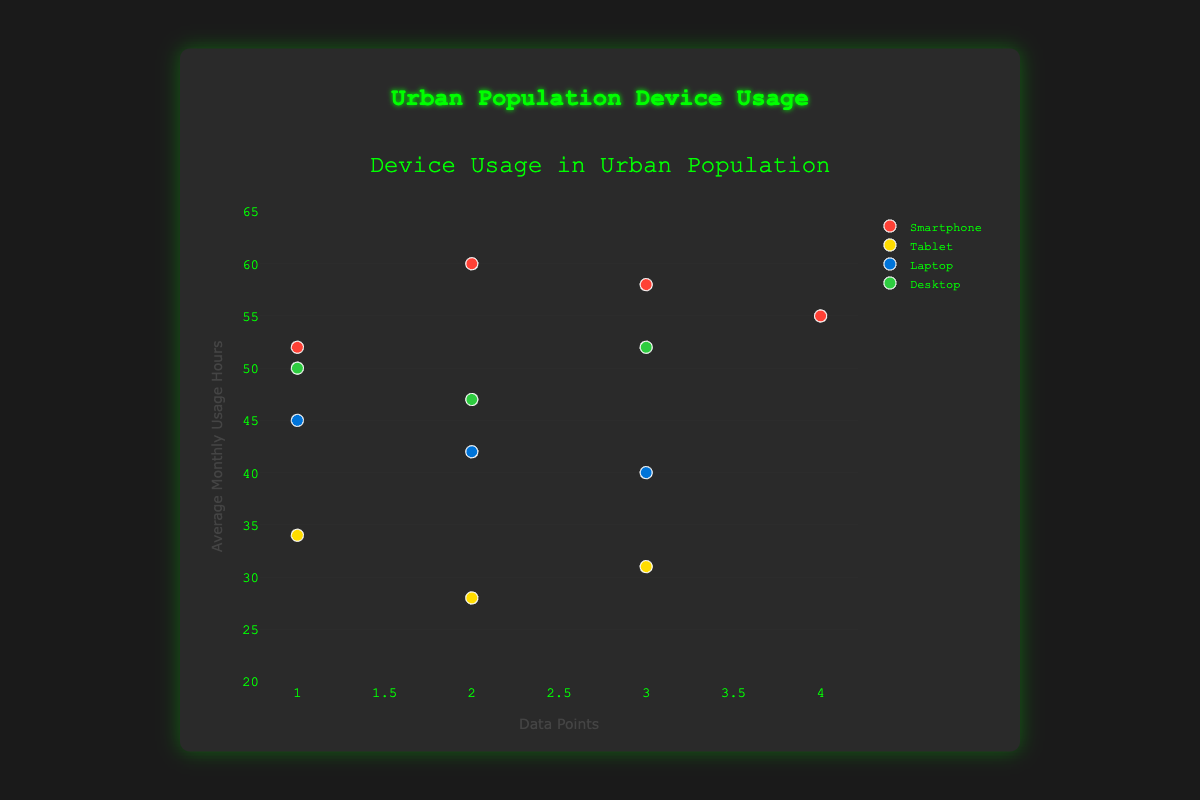How many different device types are represented in the scatter plot? The scatter plot shows different types of devices used in an urban population. By looking at the legend, you can see different markers representing different device types. There are four legend values corresponding to the device types: Smartphone, Tablet, Laptop, and Desktop
Answer: 4 Which device type has the data point with the highest average monthly usage hours? By visually inspecting the y-axis values, the highest data point is at 60 hours in the plot. Looking at the legend and the color of the marker, it is a Smartphone
Answer: Smartphone What is the range of average monthly usage hours for Desktops? To find the range, look for the minimum and maximum y-values of the "Desktop" markers in the scatter plot. The highest is 52 and the lowest is 47. The range is calculated as the difference between the maximum and minimum
Answer: 47 - 52 Comparing Smartphones and Tablets, which device type generally has higher average monthly usage hours? By comparing the y-values of the markers for Smartphones and Tablets, it's clear that the data points for Smartphones are generally higher, indicating that Smartphones have higher usage hours than Tablets
Answer: Smartphones What is the median average monthly usage hours for Laptops? First, arrange the data points for Laptops in ascending order (40, 42, 45). The median is the middle value in this ordered list
Answer: 42 Estimate the average monthly usage hours for Tablets Sum the y-values for Tablets and divide by the number of Tablet data points: (34 + 28 + 31) / 3 = 31. The average is 31
Answer: 31 Which device has more variation in usage: Laptop or Desktop? Calculate the range of usage hours for each: Laptops (45-40=5) and Desktops (52-47=5). The variation is the same, but look more closely at the spread of each in the plot. Both cover a range of 5 units, but upon visual inspection, Desktops appear more uniformly spread across the y-axis compared to Laptops
Answer: Same What is the most frequent usage hour among all device types? Look for any repeated y-axis values in the scatter plot. The usage hour "52" appears most frequently across different device types
Answer: 52 